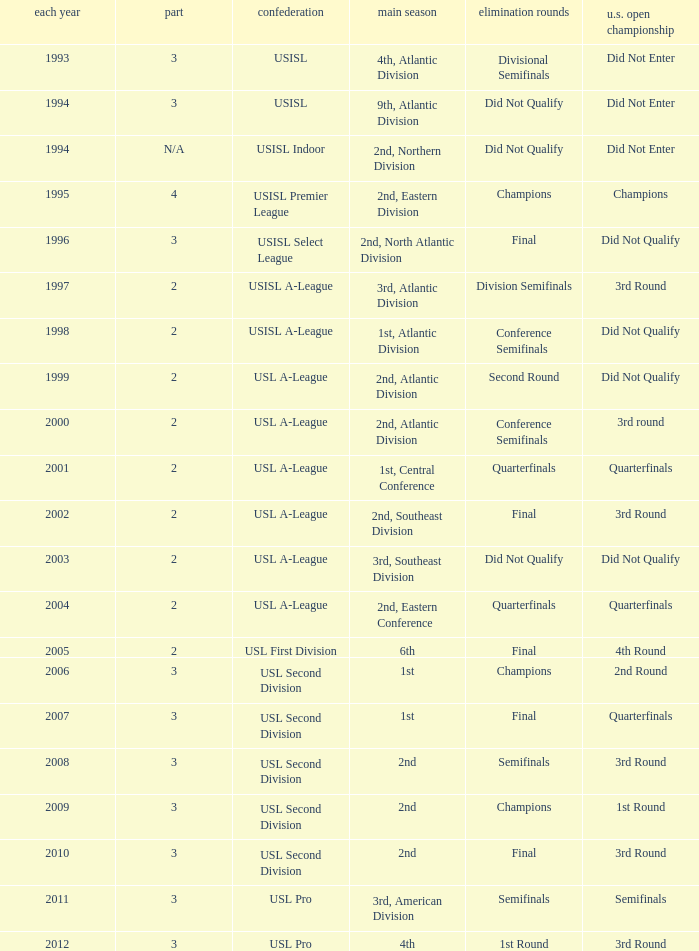What are all the playoffs for regular season is 1st, atlantic division Conference Semifinals. 